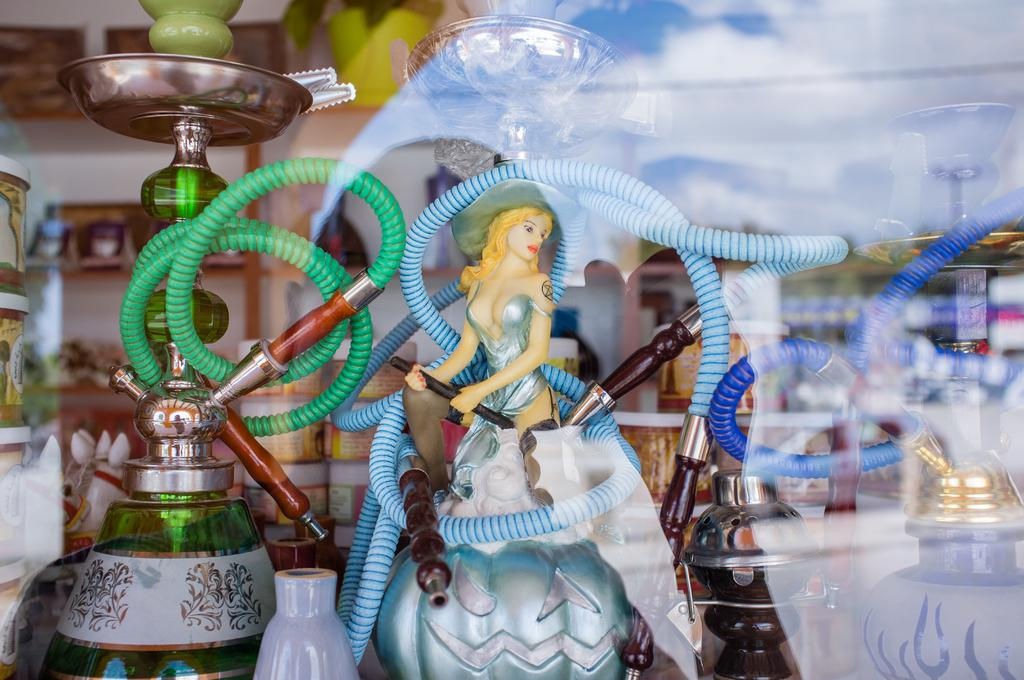What is the main subject of the image? There is a Barbie in the image. What else can be seen in the image besides the Barbie? There are toys in the image. What is visible in the background of the image? There are objects placed in racks in the background of the image. Can you describe the reflection on the right side of the image? There is a reflection on a glass on the right side of the image. What type of medical advice is the doctor giving to the pigs in the image? There are no pigs or doctors present in the image. 